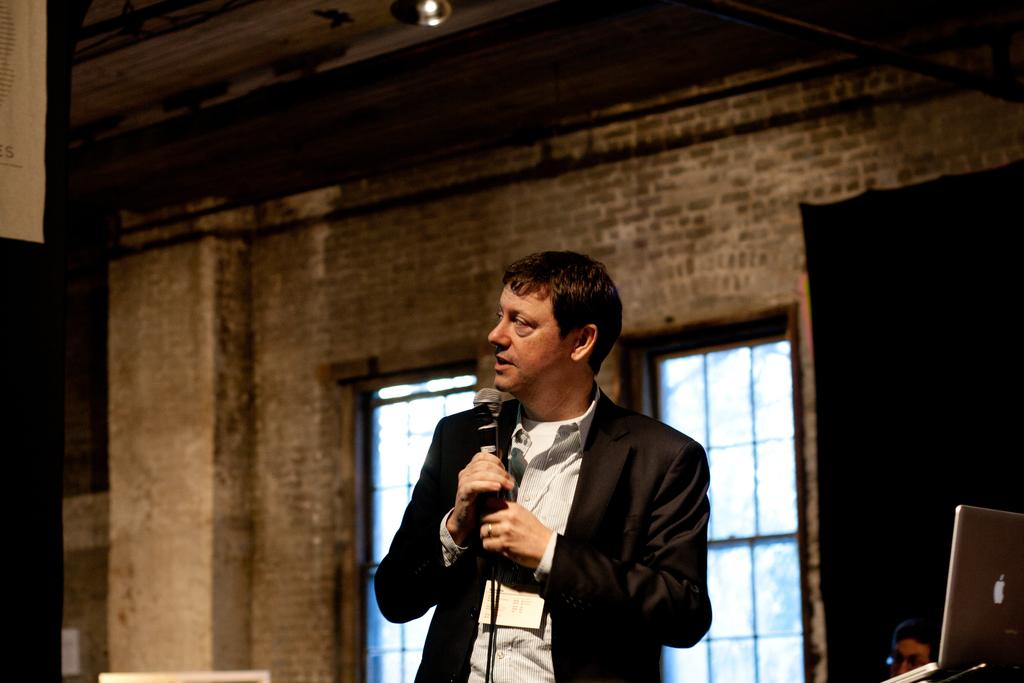What is the main subject of the image? The main subject of the image is a man. What is the man doing in the image? The man is standing in the image. What object is the man holding in his hand? The man is holding a mic in his hand. What type of taste can be experienced from the man's whistle in the image? There is no whistle present in the image, and therefore no taste can be experienced. 